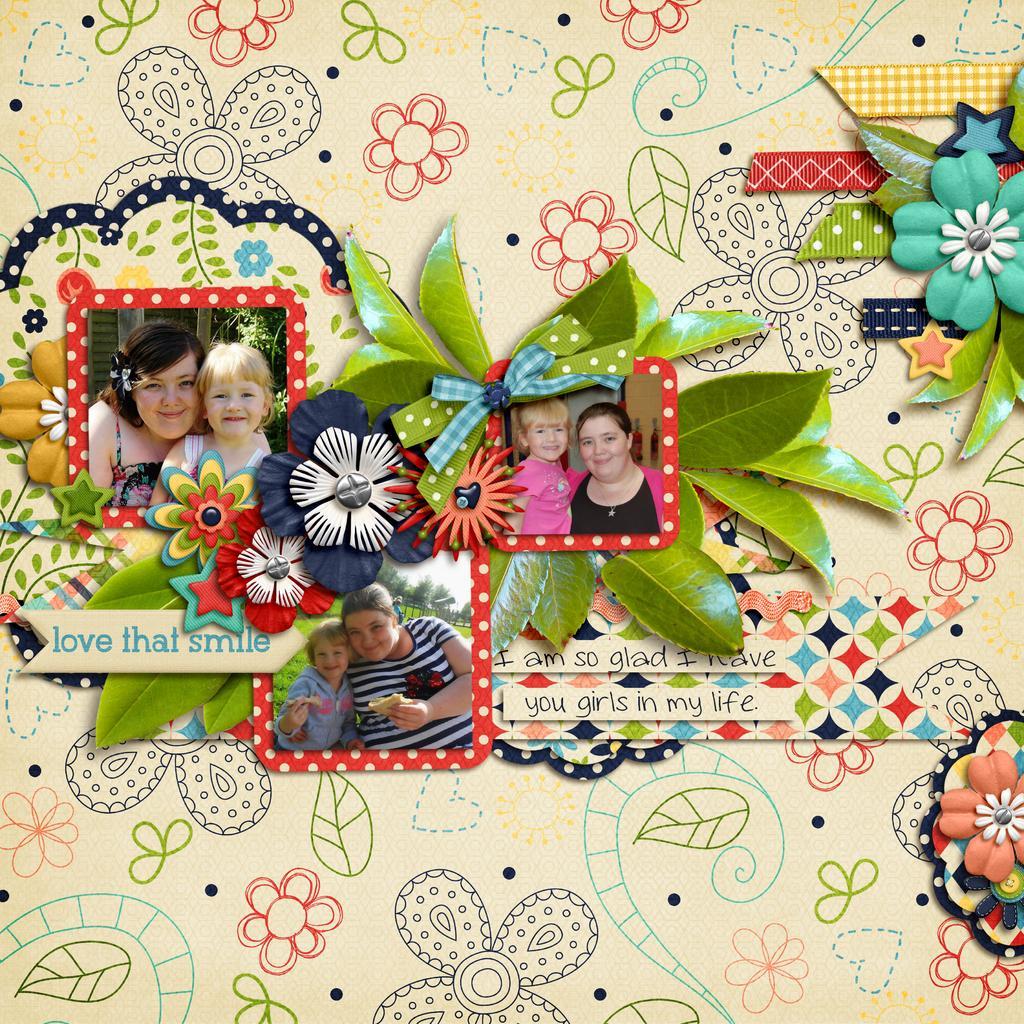In one or two sentences, can you explain what this image depicts? In the picture there is some art work done with three images and they are crafted with different materials very beautifully. 